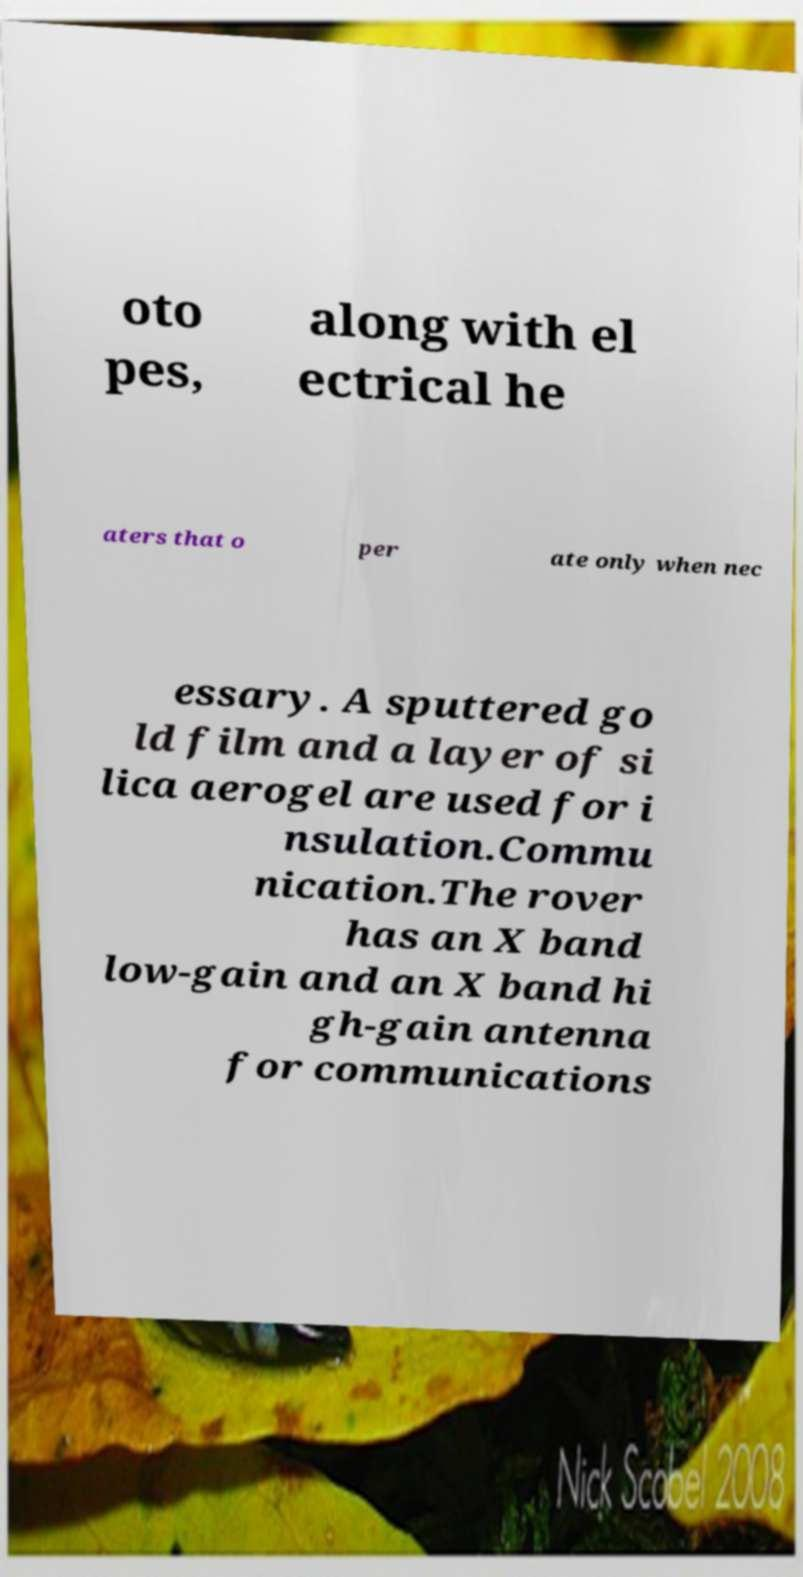Can you accurately transcribe the text from the provided image for me? oto pes, along with el ectrical he aters that o per ate only when nec essary. A sputtered go ld film and a layer of si lica aerogel are used for i nsulation.Commu nication.The rover has an X band low-gain and an X band hi gh-gain antenna for communications 